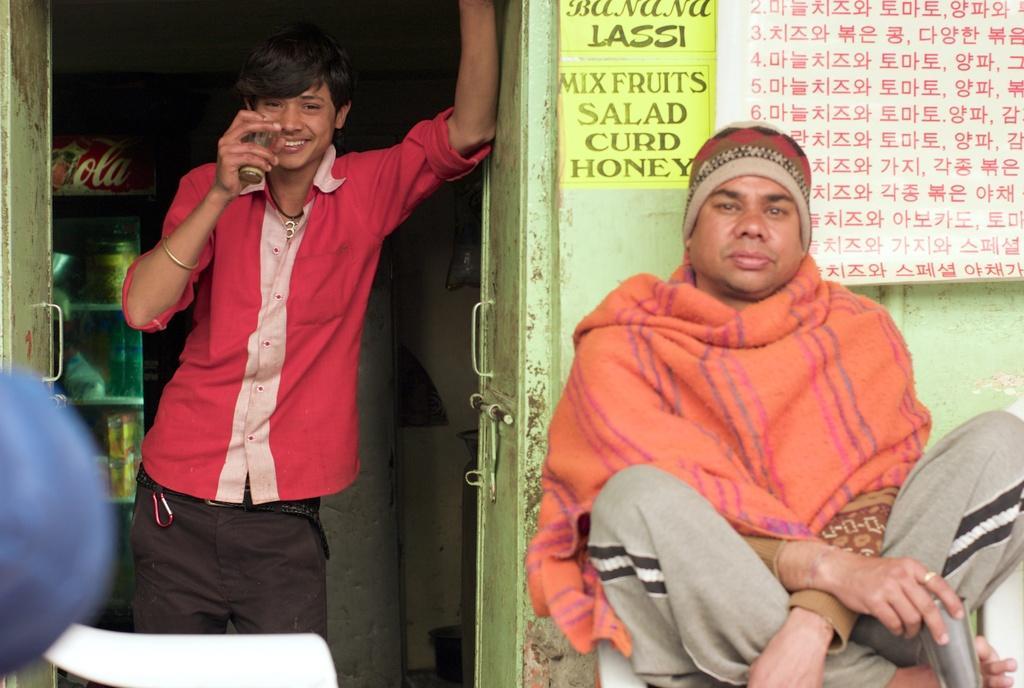Describe this image in one or two sentences. In the image we can see there is a person sitting on the bench and holding glass in his hand and beside him there is another person standing, he is holding glass and he is wearing red colour t-shirt. There are papers pasted on the wall. 